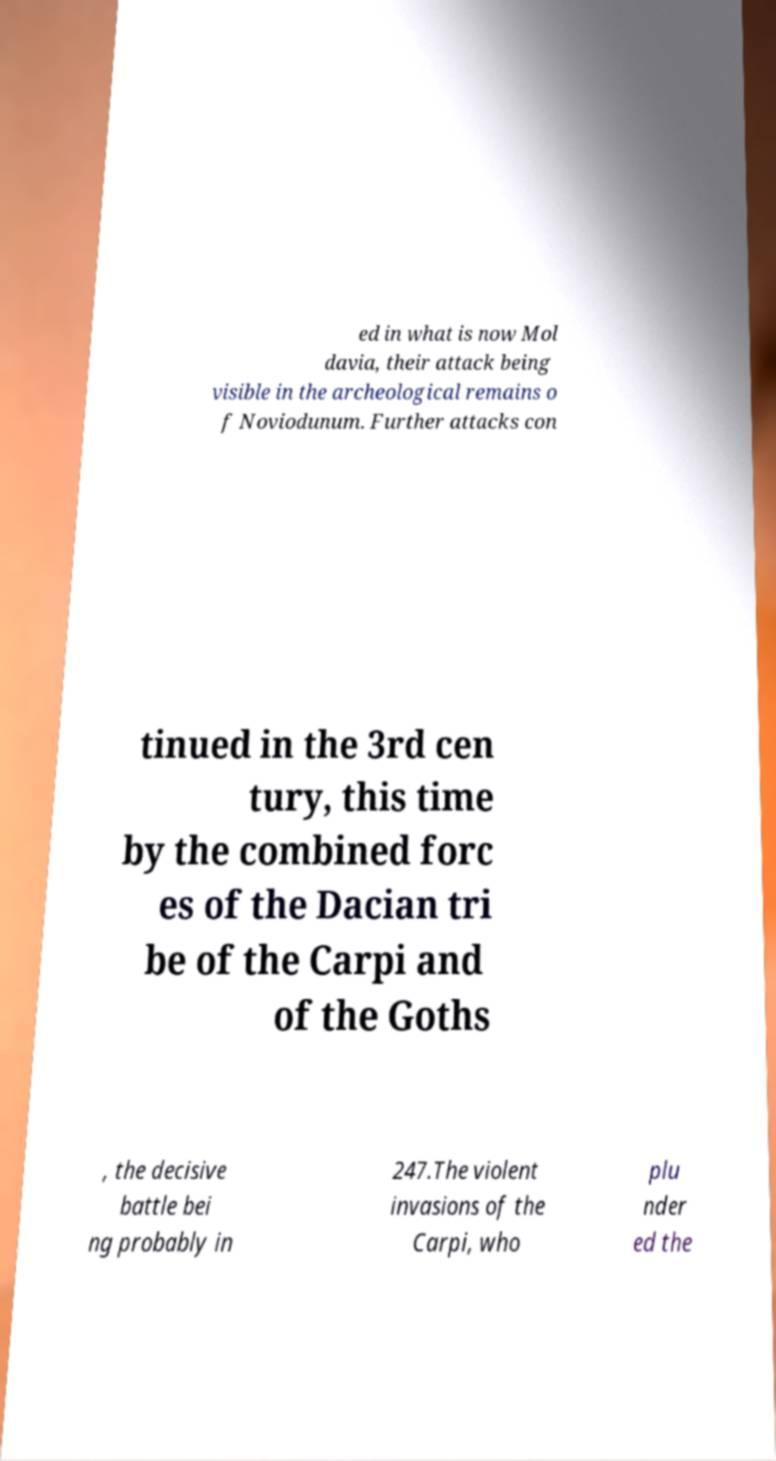I need the written content from this picture converted into text. Can you do that? ed in what is now Mol davia, their attack being visible in the archeological remains o f Noviodunum. Further attacks con tinued in the 3rd cen tury, this time by the combined forc es of the Dacian tri be of the Carpi and of the Goths , the decisive battle bei ng probably in 247.The violent invasions of the Carpi, who plu nder ed the 